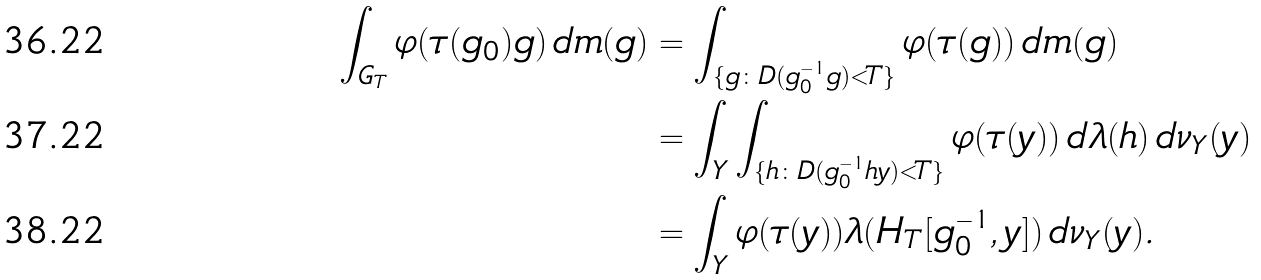<formula> <loc_0><loc_0><loc_500><loc_500>\int _ { G _ { T } } \varphi ( \tau ( g _ { 0 } ) g ) \, d m ( g ) & = \int _ { \{ g \colon D ( g _ { 0 } ^ { - 1 } g ) < T \} } \varphi ( \tau ( g ) ) \, d m ( g ) \\ & = \int _ { Y } \int _ { \{ h \colon D ( g _ { 0 } ^ { - 1 } h y ) < T \} } \varphi ( \tau ( y ) ) \, d \lambda ( h ) \, d \nu _ { Y } ( y ) \\ & = \int _ { Y } \varphi ( \tau ( y ) ) \lambda ( H _ { T } [ g _ { 0 } ^ { - 1 } , y ] ) \, d \nu _ { Y } ( y ) .</formula> 